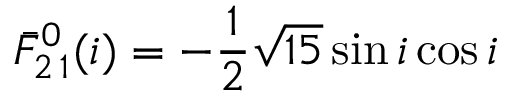Convert formula to latex. <formula><loc_0><loc_0><loc_500><loc_500>\bar { F } _ { 2 \, 1 } ^ { 0 } ( i ) = - \frac { 1 } { 2 } \sqrt { 1 5 } \sin i \cos i</formula> 